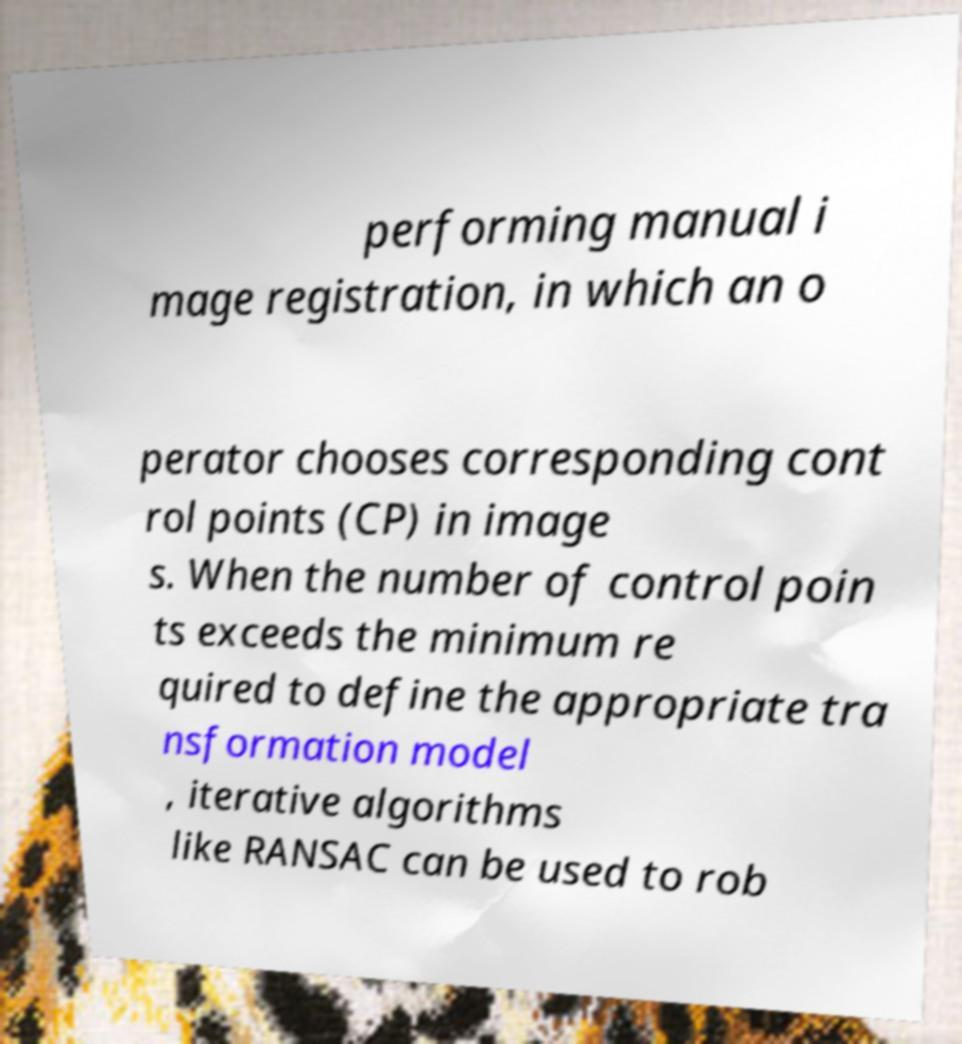Could you assist in decoding the text presented in this image and type it out clearly? performing manual i mage registration, in which an o perator chooses corresponding cont rol points (CP) in image s. When the number of control poin ts exceeds the minimum re quired to define the appropriate tra nsformation model , iterative algorithms like RANSAC can be used to rob 